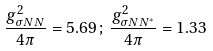<formula> <loc_0><loc_0><loc_500><loc_500>\frac { g ^ { 2 } _ { \sigma N N } } { 4 \pi } = 5 . 6 9 \, ; \, \frac { g ^ { 2 } _ { \sigma N N ^ { * } } } { 4 \pi } = 1 . 3 3</formula> 